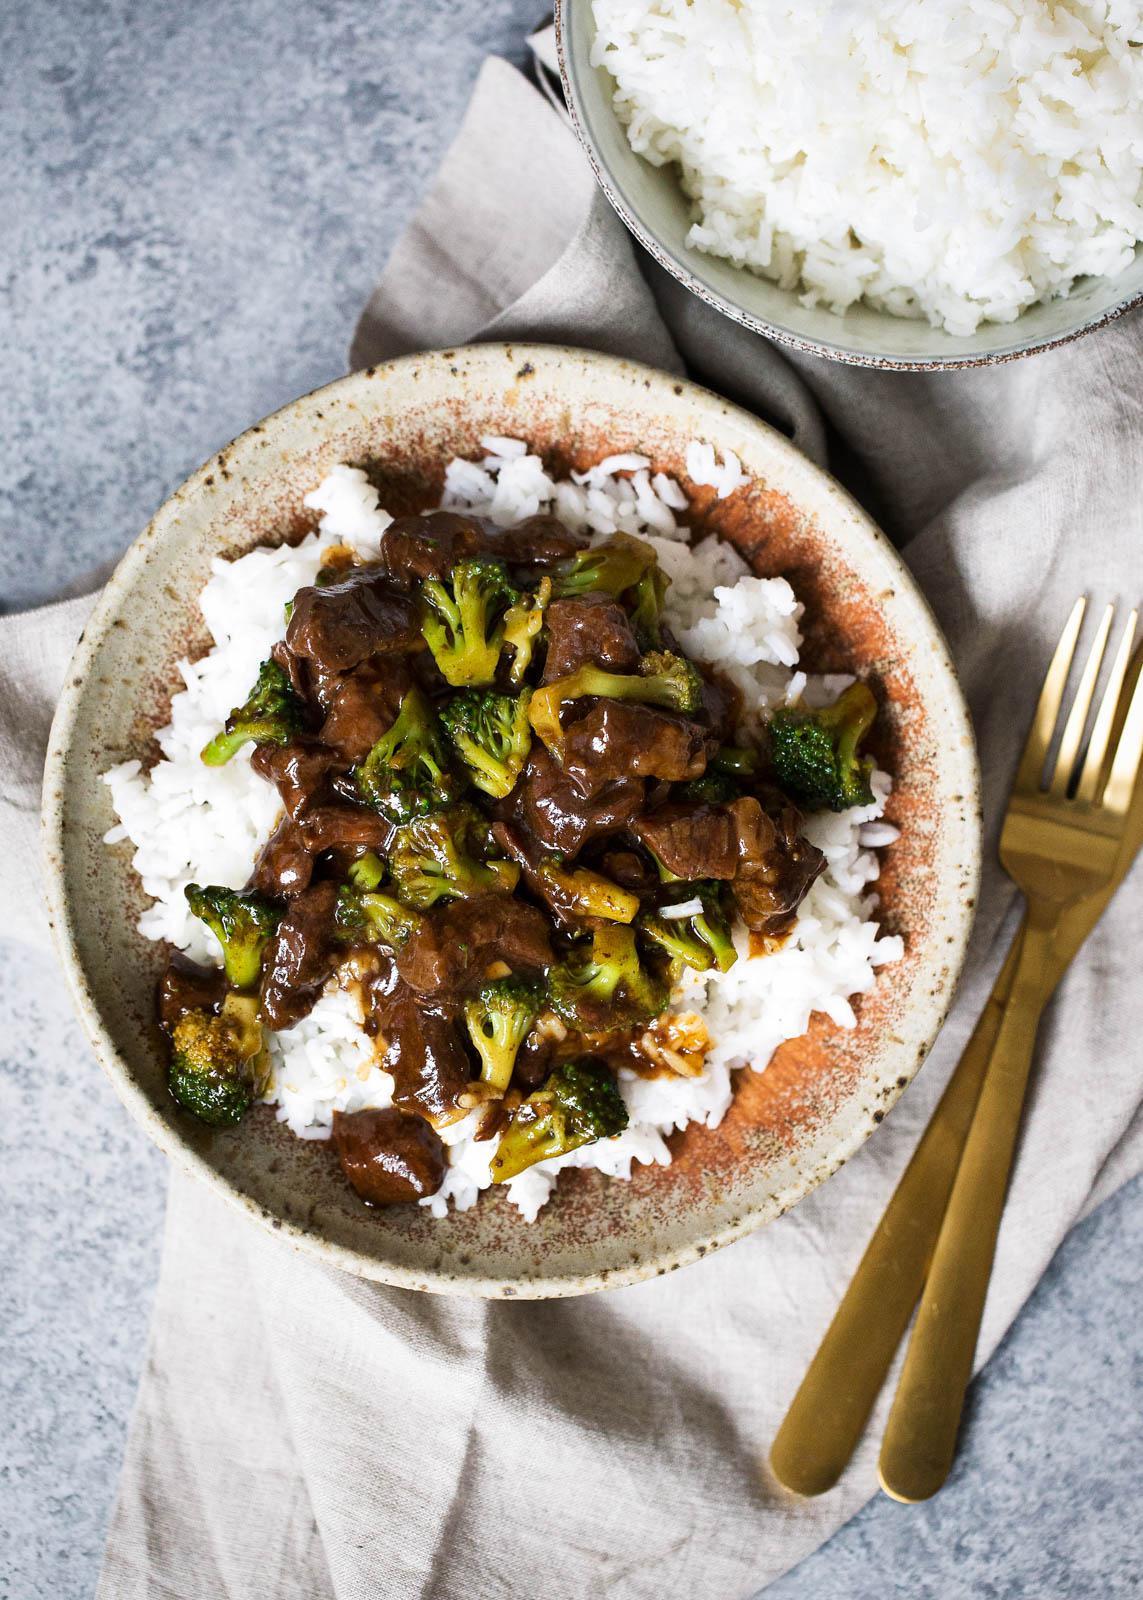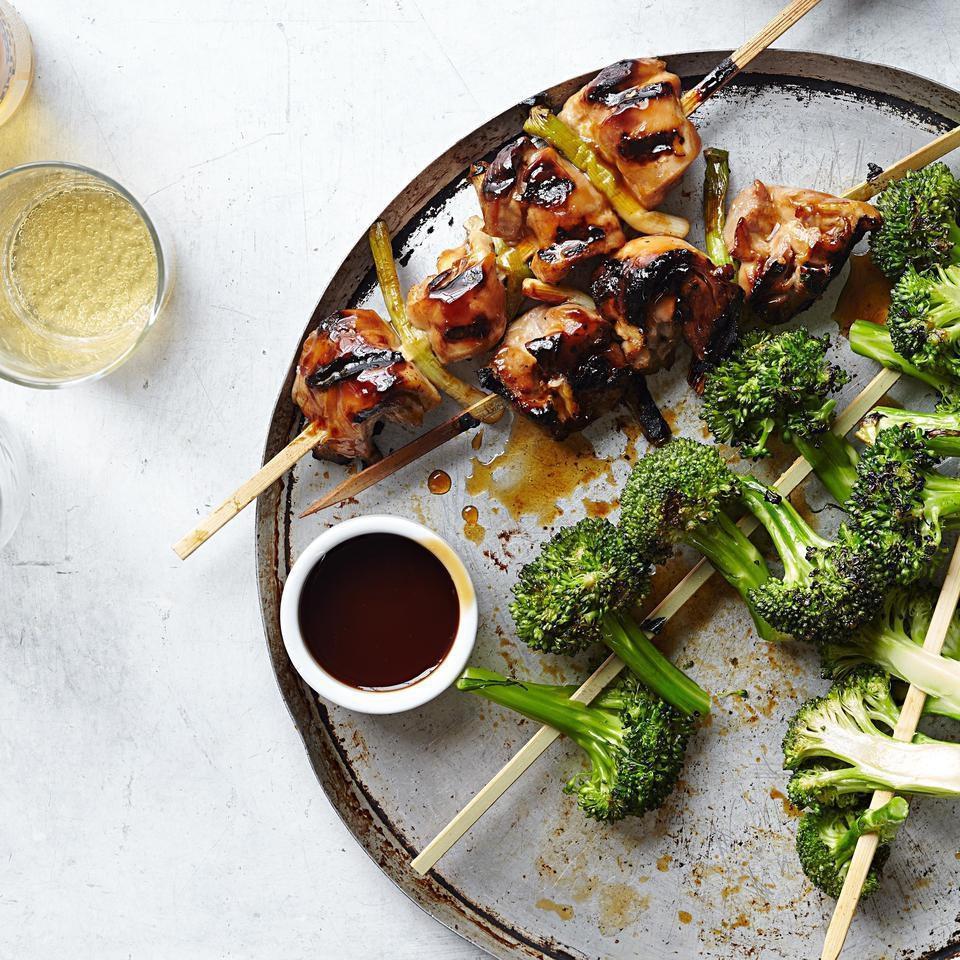The first image is the image on the left, the second image is the image on the right. Examine the images to the left and right. Is the description "An image shows two silverware utensils on a white napkin next to a broccoli dish." accurate? Answer yes or no. Yes. The first image is the image on the left, the second image is the image on the right. Evaluate the accuracy of this statement regarding the images: "One of the dishes contains broccoli and spiral pasta.". Is it true? Answer yes or no. No. 